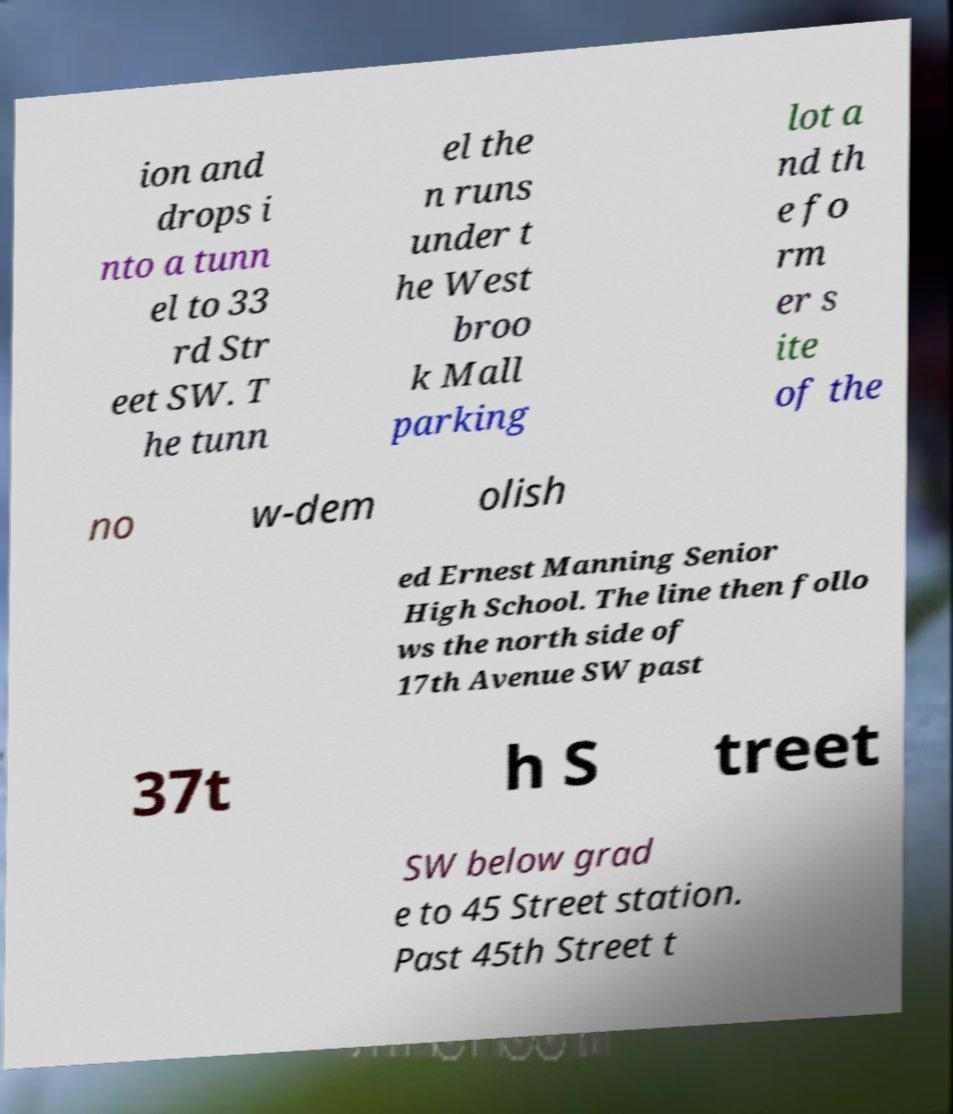There's text embedded in this image that I need extracted. Can you transcribe it verbatim? ion and drops i nto a tunn el to 33 rd Str eet SW. T he tunn el the n runs under t he West broo k Mall parking lot a nd th e fo rm er s ite of the no w-dem olish ed Ernest Manning Senior High School. The line then follo ws the north side of 17th Avenue SW past 37t h S treet SW below grad e to 45 Street station. Past 45th Street t 